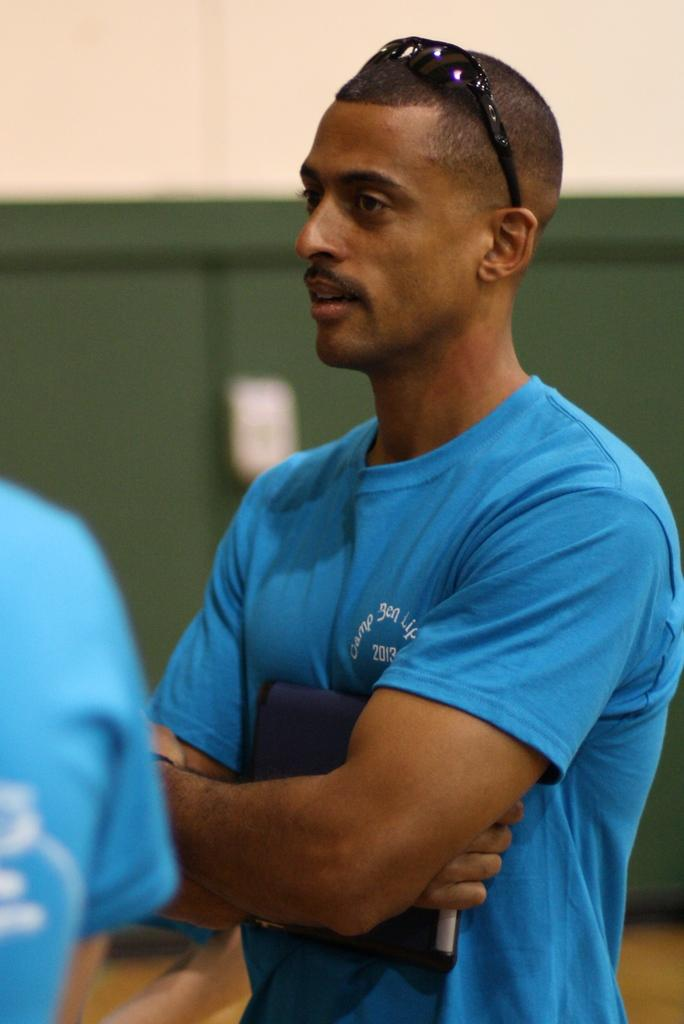Who or what is present in the image? There is a person in the image. Can you describe the person's appearance? The person is wearing glasses. What is the person holding in the image? The person is holding an object. What else can be seen on the left side of the image? There is a human hand visible on the left side of the image. What type of truck can be seen parked next to the person in the image? There is no truck present in the image; it only features a person, glasses, an object, and a human hand. 